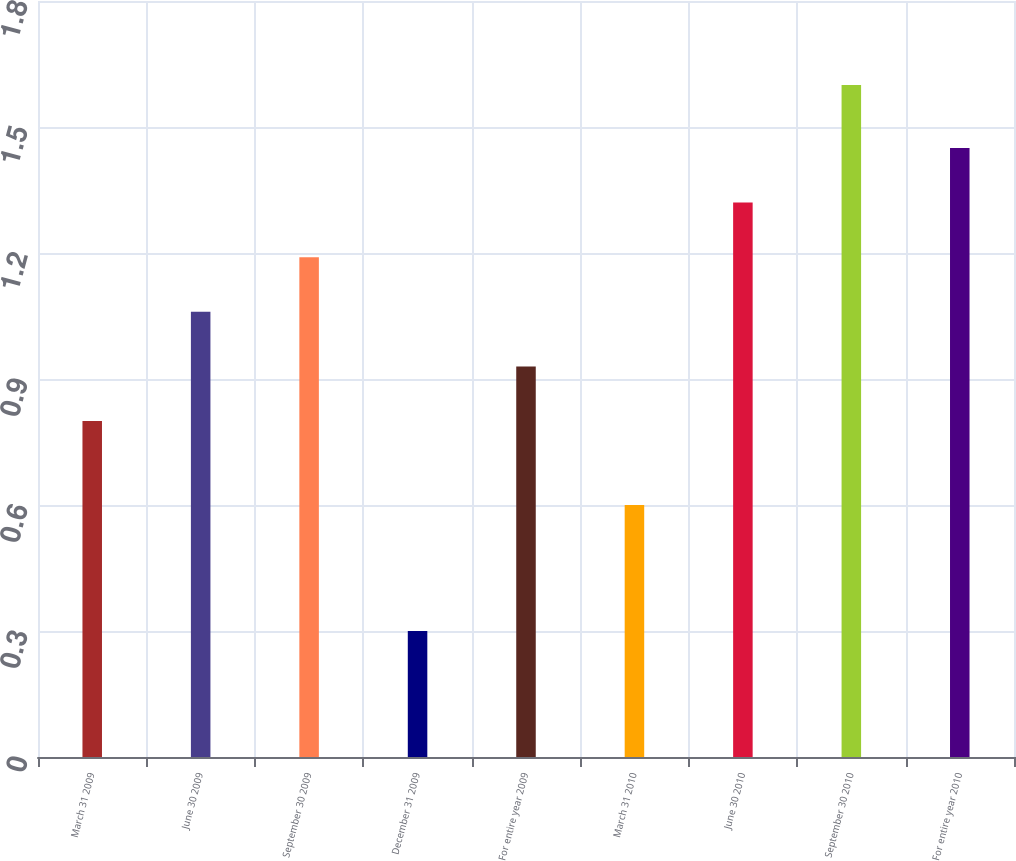Convert chart to OTSL. <chart><loc_0><loc_0><loc_500><loc_500><bar_chart><fcel>March 31 2009<fcel>June 30 2009<fcel>September 30 2009<fcel>December 31 2009<fcel>For entire year 2009<fcel>March 31 2010<fcel>June 30 2010<fcel>September 30 2010<fcel>For entire year 2010<nl><fcel>0.8<fcel>1.06<fcel>1.19<fcel>0.3<fcel>0.93<fcel>0.6<fcel>1.32<fcel>1.6<fcel>1.45<nl></chart> 